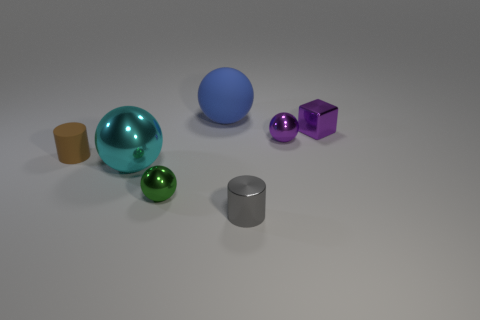Subtract all purple cylinders. Subtract all brown cubes. How many cylinders are left? 2 Add 2 purple things. How many objects exist? 9 Subtract all cylinders. How many objects are left? 5 Add 4 purple metallic things. How many purple metallic things are left? 6 Add 1 large red things. How many large red things exist? 1 Subtract 0 yellow balls. How many objects are left? 7 Subtract all green spheres. Subtract all tiny green shiny objects. How many objects are left? 5 